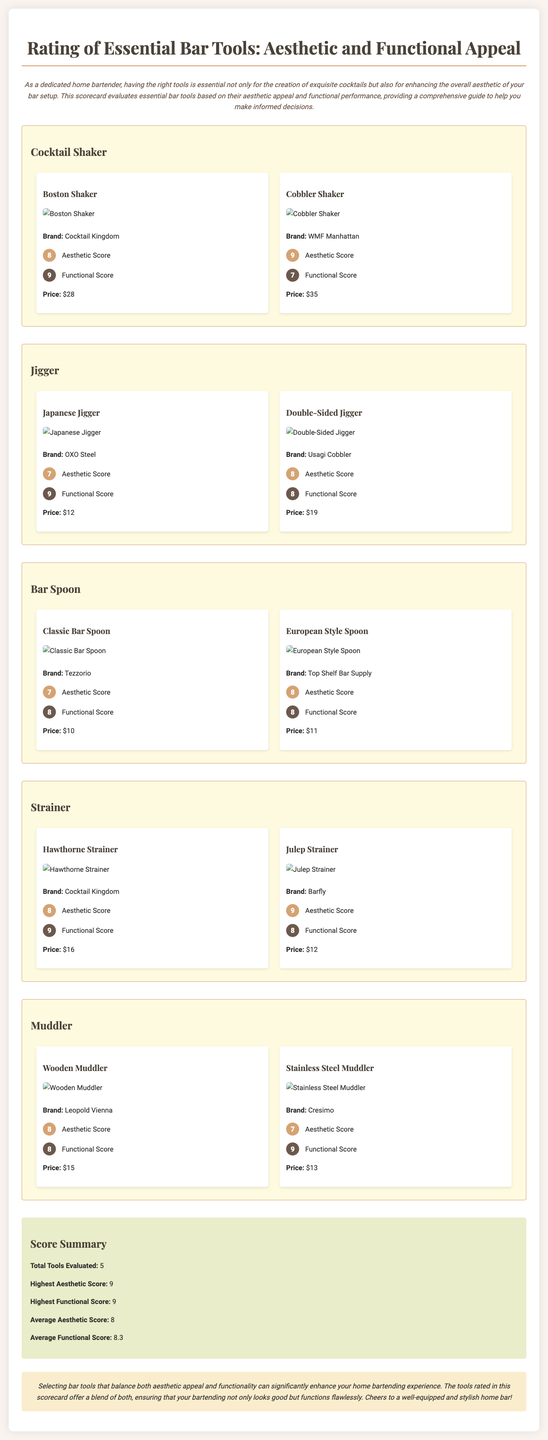What is the highest aesthetic score? The highest aesthetic score recorded in the scorecard for bar tools is 9.
Answer: 9 What is the brand of the Boston Shaker? The scorecard lists "Cocktail Kingdom" as the brand of the Boston Shaker.
Answer: Cocktail Kingdom What is the price of the Double-Sided Jigger? The price listed for the Double-Sided Jigger in the document is $19.
Answer: $19 Which tool has the lowest aesthetic score? The Classic Bar Spoon has an aesthetic score of 7, which is the lowest among the tools evaluated.
Answer: Classic Bar Spoon What is the average functional score for the tools? The average functional score calculated for the tools evaluated in the scorecard is 8.3.
Answer: 8.3 How many total tools were evaluated? The score summary indicates that a total of 5 tools were evaluated.
Answer: 5 